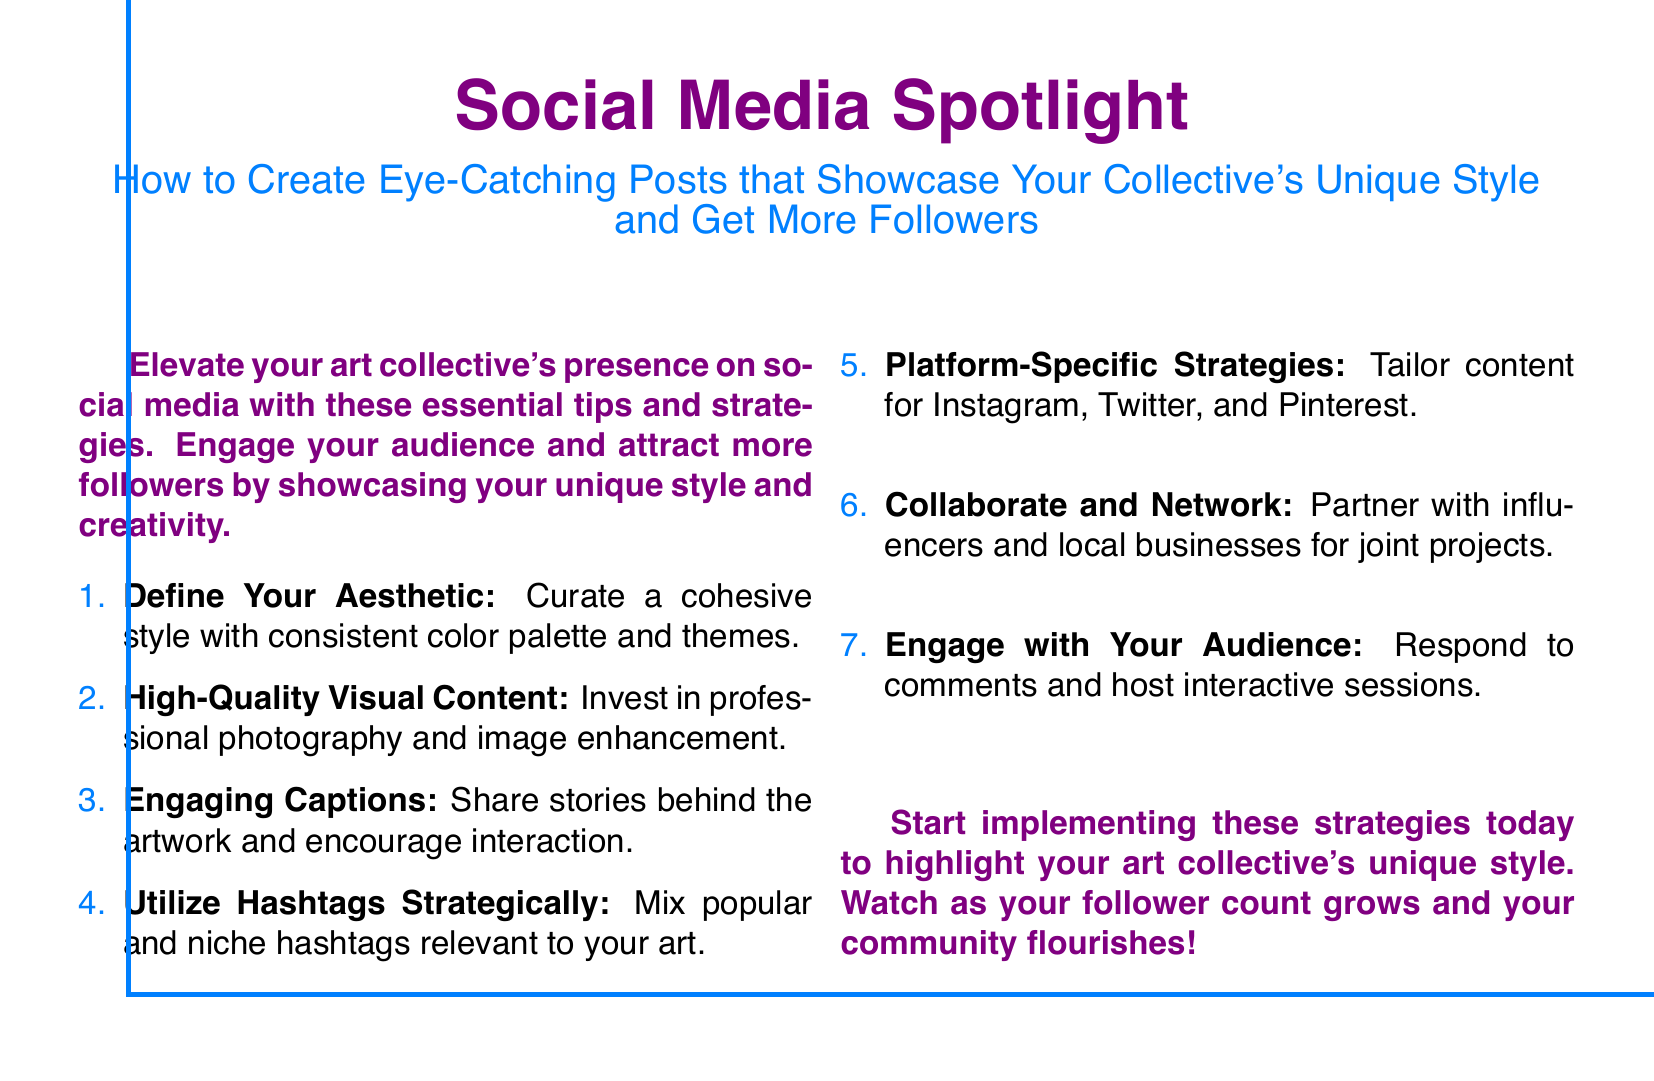what is the main title of the document? The main title is prominently displayed at the top of the document and is "Social Media Spotlight".
Answer: Social Media Spotlight what is the subtitle of the document? The subtitle accompanies the main title and provides specific details on the focus of the advertisement.
Answer: How to Create Eye-Catching Posts that Showcase Your Collective's Unique Style and Get More Followers how many tips are listed in the document? The document enumerates a series of tips presented in a list format.
Answer: 7 what color is used for the main title? The title is designed in a specific color that stands out for visual emphasis.
Answer: artpurple which social media platforms are mentioned for tailoring content? The document suggests specific platforms to tailor content for, thereby addressing audience preferences.
Answer: Instagram, Twitter, and Pinterest what is one of the strategies for engaging with the audience? The document outlines various strategies and includes specific suggestions for audience engagement.
Answer: Respond to comments what is suggested for enhancing visual content? The document emphasizes the importance of quality in visual representations within social media posts.
Answer: Invest in professional photography what is the overall purpose of the advertisement? The advertisement outlines its intent to help art collectives improve their online presence and engagement.
Answer: To highlight art collective's unique style and grow follower count 